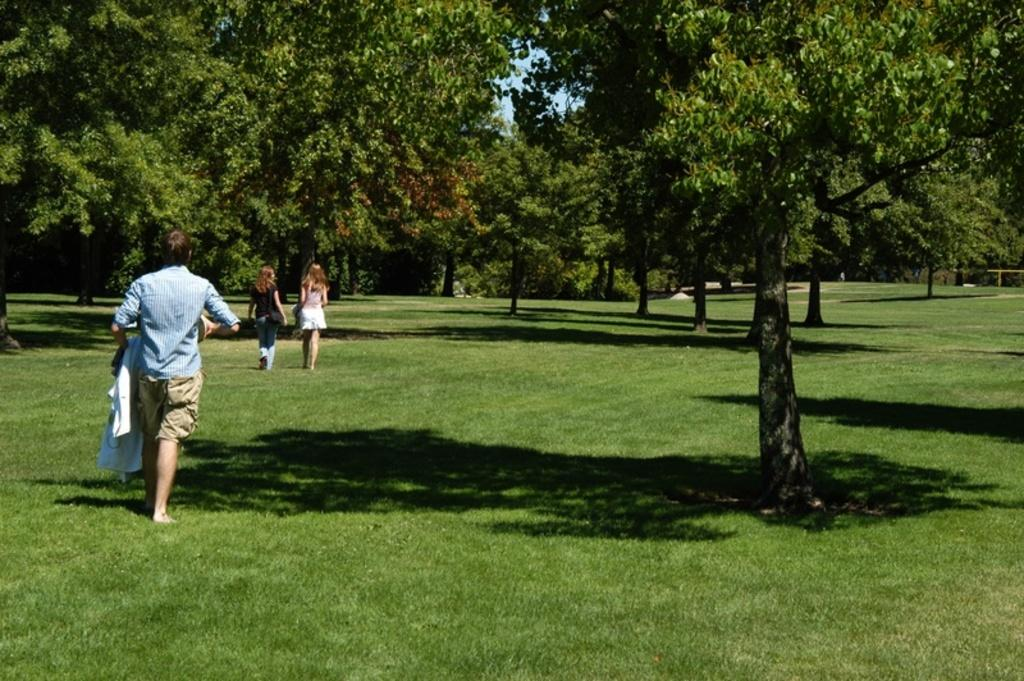What are the people in the image doing? There are persons walking in the image. What type of vegetation can be seen in the image? There are trees in the image. What is the ground covered with in the image? There is grass on the ground in the image. What type of bat can be seen hanging from the tree in the image? There is no bat visible in the image; only trees and grass are present. 